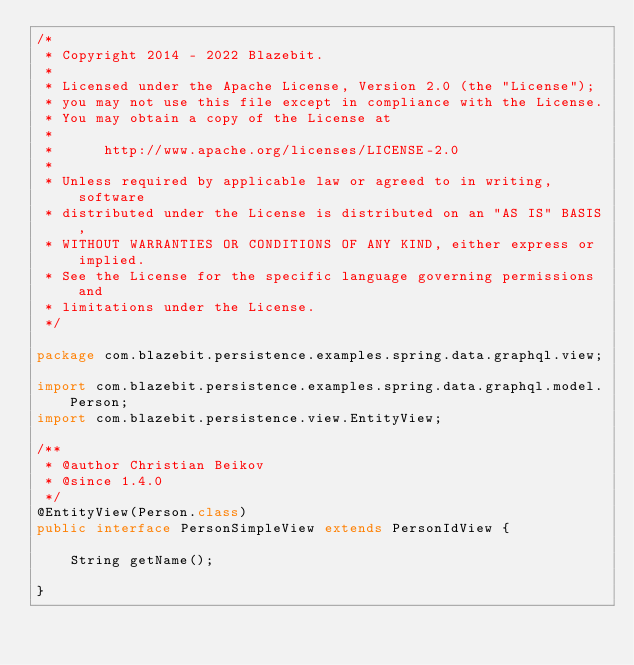<code> <loc_0><loc_0><loc_500><loc_500><_Java_>/*
 * Copyright 2014 - 2022 Blazebit.
 *
 * Licensed under the Apache License, Version 2.0 (the "License");
 * you may not use this file except in compliance with the License.
 * You may obtain a copy of the License at
 *
 *      http://www.apache.org/licenses/LICENSE-2.0
 *
 * Unless required by applicable law or agreed to in writing, software
 * distributed under the License is distributed on an "AS IS" BASIS,
 * WITHOUT WARRANTIES OR CONDITIONS OF ANY KIND, either express or implied.
 * See the License for the specific language governing permissions and
 * limitations under the License.
 */

package com.blazebit.persistence.examples.spring.data.graphql.view;

import com.blazebit.persistence.examples.spring.data.graphql.model.Person;
import com.blazebit.persistence.view.EntityView;

/**
 * @author Christian Beikov
 * @since 1.4.0
 */
@EntityView(Person.class)
public interface PersonSimpleView extends PersonIdView {

    String getName();

}
</code> 